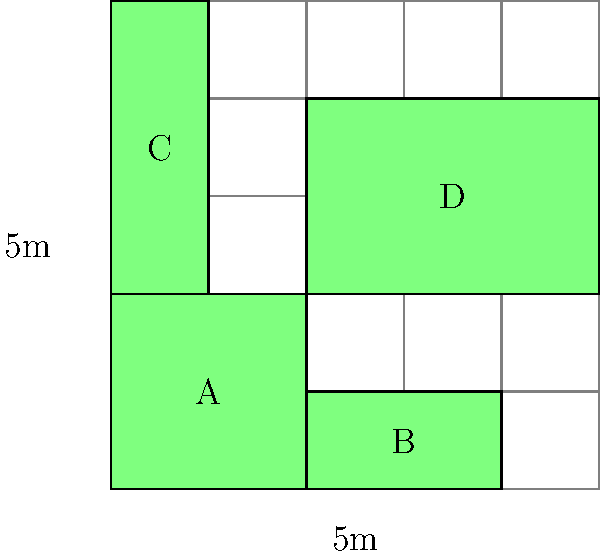You are planning a community garden on a 5m x 5m grid, divided into four plots (A, B, C, and D) as shown in the diagram. If the optimal planting density is 1 plant per square meter, and you want to allocate space proportionally based on the needs of different vegetable types, how many plants should be grown in plot D? To solve this problem, we need to follow these steps:

1. Calculate the total area of the garden:
   Total area = 5m × 5m = 25 m²

2. Calculate the areas of each plot:
   Plot A: 2m × 2m = 4 m²
   Plot B: 2m × 1m = 2 m²
   Plot C: 1m × 3m = 3 m²
   Plot D: 3m × 2m = 6 m²

3. Verify the total area:
   4 + 2 + 3 + 6 = 15 m² (The remaining 10 m² are pathways)

4. Calculate the proportion of plantable area for plot D:
   Proportion = Area of plot D / Total plantable area
   $\frac{6 \text{ m}²}{15 \text{ m}²} = 0.4$ or 40%

5. Calculate the number of plants for plot D:
   Given the optimal planting density of 1 plant per square meter,
   Number of plants in plot D = Area of plot D × Planting density
   = 6 m² × 1 plant/m² = 6 plants

Therefore, 6 plants should be grown in plot D.
Answer: 6 plants 